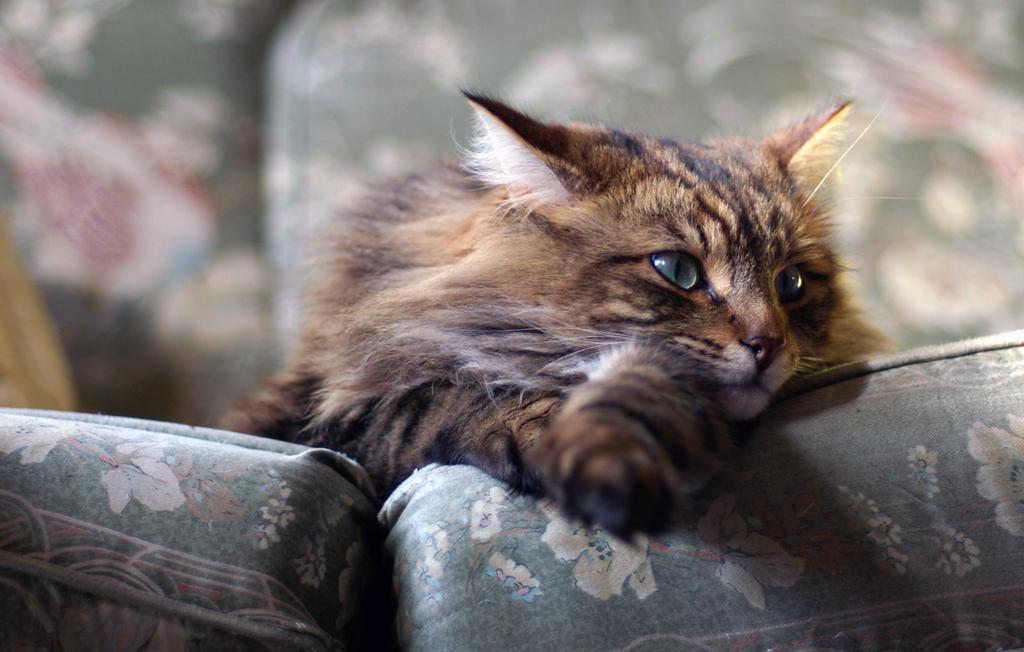Please provide a concise description of this image. In the center of the image we can see a cat lying on the sofa. 